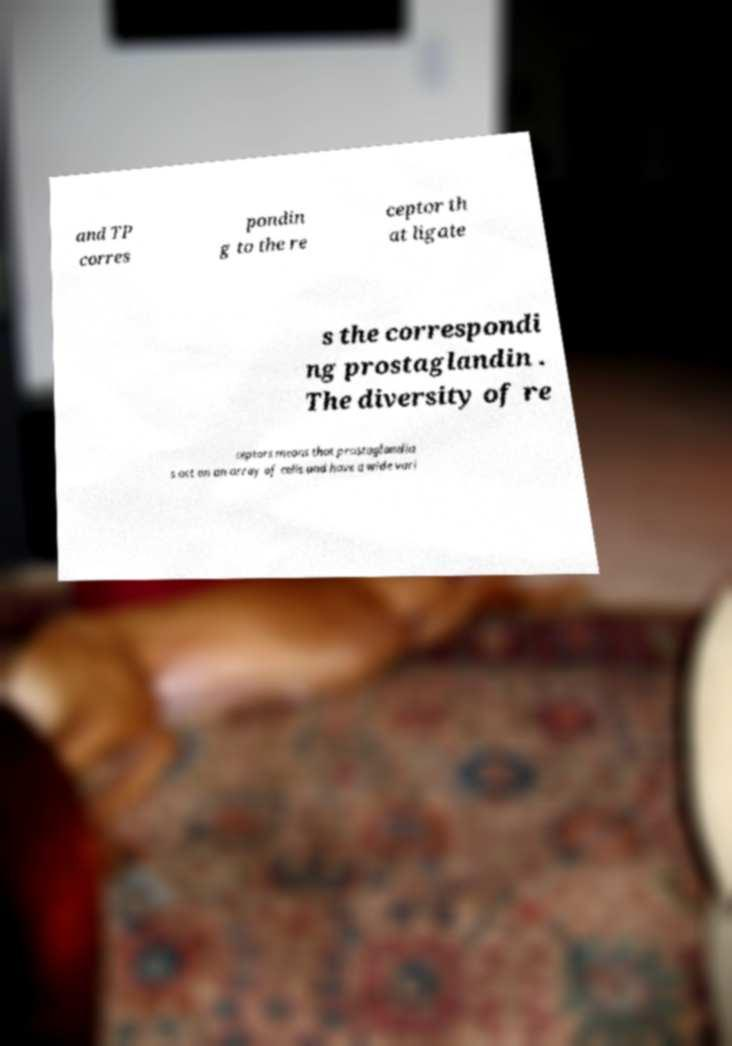Please read and relay the text visible in this image. What does it say? and TP corres pondin g to the re ceptor th at ligate s the correspondi ng prostaglandin . The diversity of re ceptors means that prostaglandin s act on an array of cells and have a wide vari 